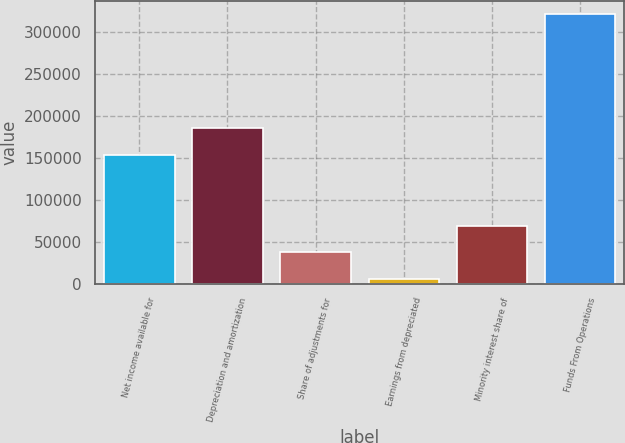Convert chart. <chart><loc_0><loc_0><loc_500><loc_500><bar_chart><fcel>Net income available for<fcel>Depreciation and amortization<fcel>Share of adjustments for<fcel>Earnings from depreciated<fcel>Minority interest share of<fcel>Funds From Operations<nl><fcel>153969<fcel>185563<fcel>37542.7<fcel>5949<fcel>69136.4<fcel>321886<nl></chart> 